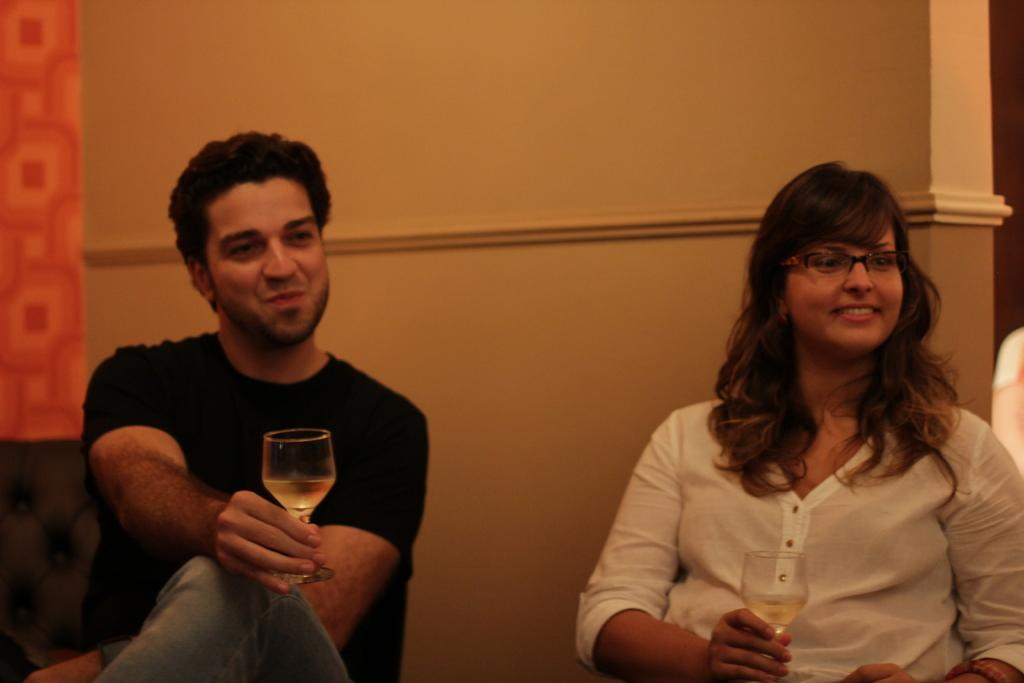What is the color of the wall in the image? The wall in the image is yellow. How many people are in the image? There are two persons in the image. What are the persons holding in their hands? The persons are holding glasses. Can you see a stream flowing behind the persons in the image? There is no stream visible in the image; it only features a yellow wall and two persons holding glasses. 